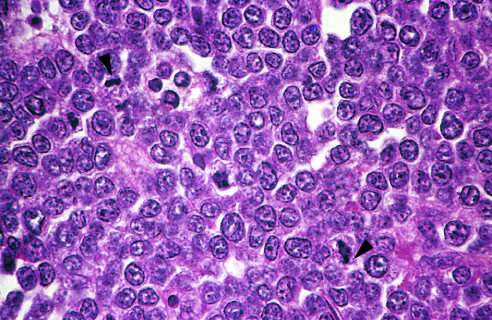the tumor cells and whose nuclei are fairly uniform , giving a monotonous appearance?
Answer the question using a single word or phrase. Their 